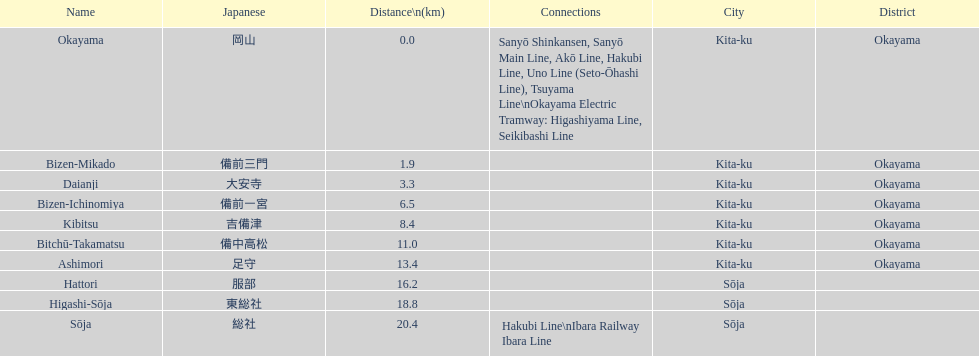Which has a distance of more than 1 kilometer but less than 2 kilometers? Bizen-Mikado. 